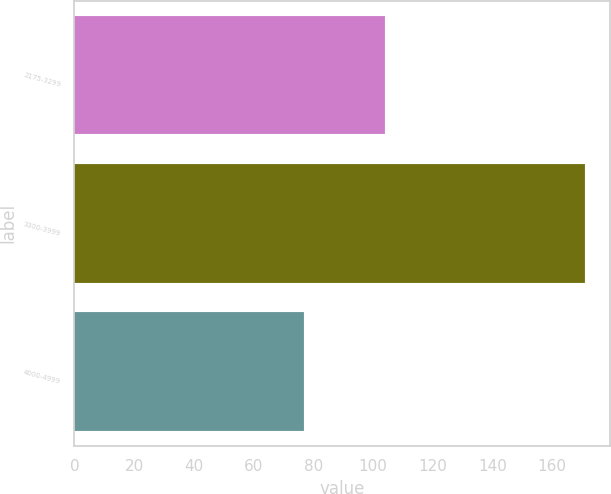<chart> <loc_0><loc_0><loc_500><loc_500><bar_chart><fcel>2175-3299<fcel>3300-3999<fcel>4000-4999<nl><fcel>104<fcel>171<fcel>77<nl></chart> 